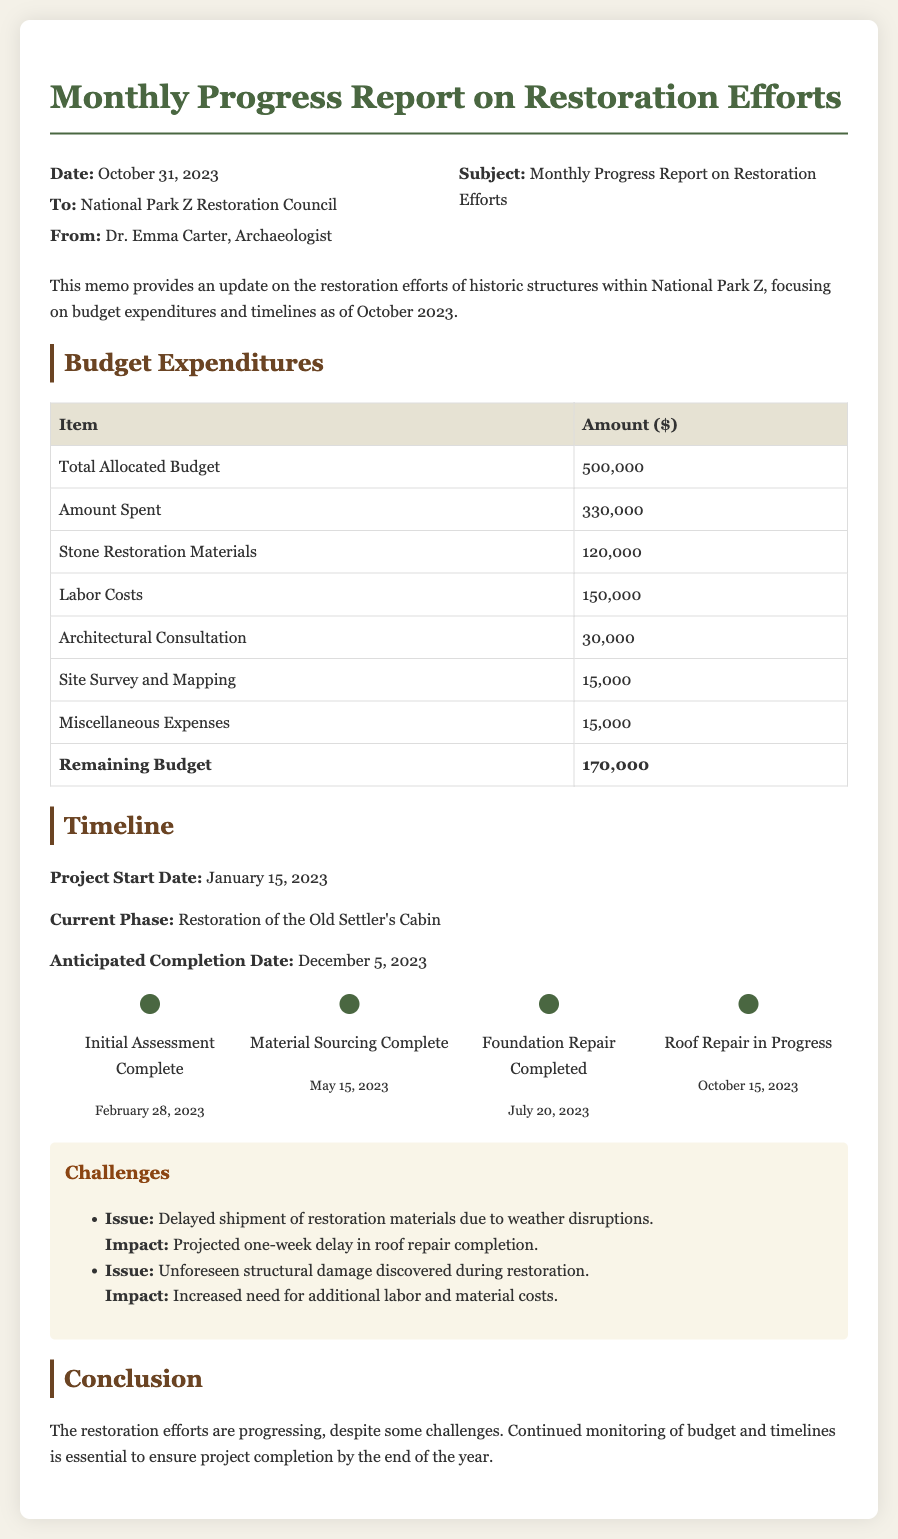what is the total allocated budget? The total allocated budget is specified in the budget expenditures section of the document as 500,000 dollars.
Answer: 500,000 how much has been spent so far? The amount spent is detailed in the budget table, which states an expenditure of 330,000 dollars.
Answer: 330,000 what is the current phase of the restoration project? The current phase is mentioned in the timeline section as "Restoration of the Old Settler's Cabin."
Answer: Restoration of the Old Settler's Cabin when is the anticipated completion date? The anticipated completion date is listed in the timeline section as December 5, 2023.
Answer: December 5, 2023 what challenge is impacting the roof repair? The challenge impacting the roof repair is a "Delayed shipment of restoration materials due to weather disruptions."
Answer: Delayed shipment of restoration materials how much is the remaining budget after expenses? The remaining budget can be calculated from the budget table, which shows it as 170,000 dollars.
Answer: 170,000 when did the initial assessment complete? The completion date of the initial assessment is stated in the timeline section as February 28, 2023.
Answer: February 28, 2023 who is the author of the memo? The author of the memo is indicated at the top of the document as Dr. Emma Carter, Archaeologist.
Answer: Dr. Emma Carter what issue was discovered during the restoration? The issue discovered during the restoration is stated as "Unforeseen structural damage."
Answer: Unforeseen structural damage 